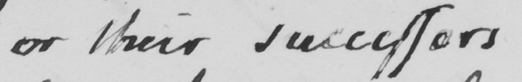Please transcribe the handwritten text in this image. or their successors 